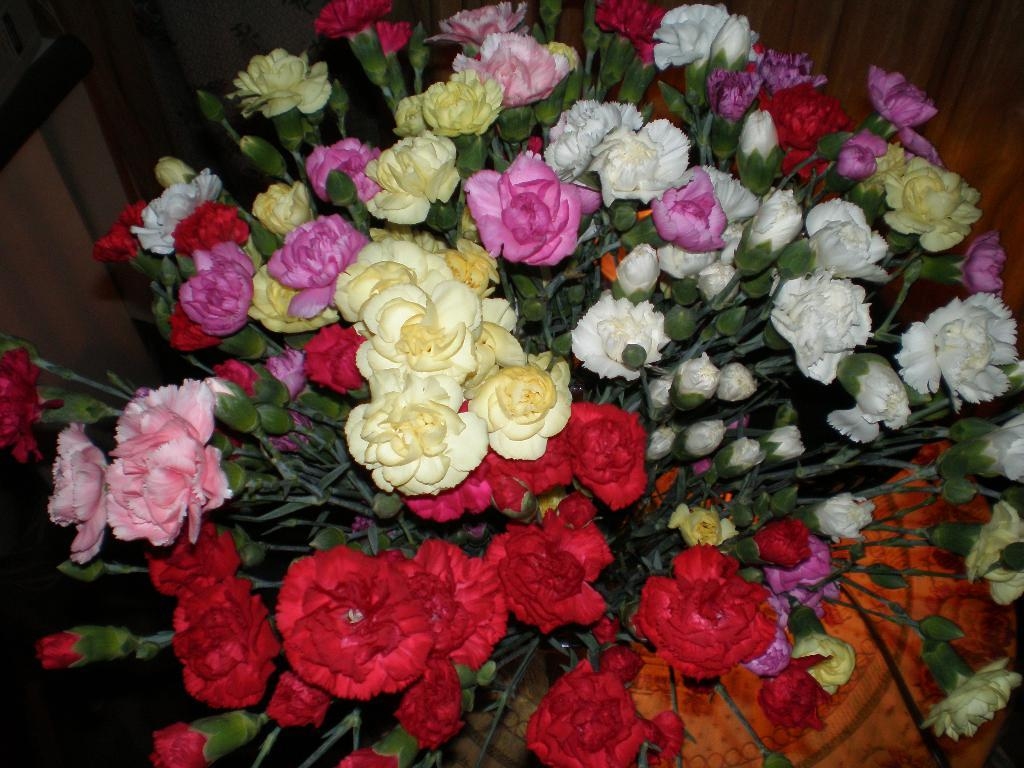What type of plant is depicted in the image? There are stems with flowers in the image. What other features can be seen on the stems? The stems have leaves in the image. Are there any unopened flowers on the stems? Yes, there are buds on the stems in the image. What material is present in the top right corner of the image? There is a wooden material in the top right corner of the image. Can you see a boat sailing in the background of the image? There is no boat present in the image; it features stems with flowers, leaves, and buds. What type of bun is being used to hold the flowers together in the image? There is no bun present in the image; it features stems with flowers, leaves, and buds. 